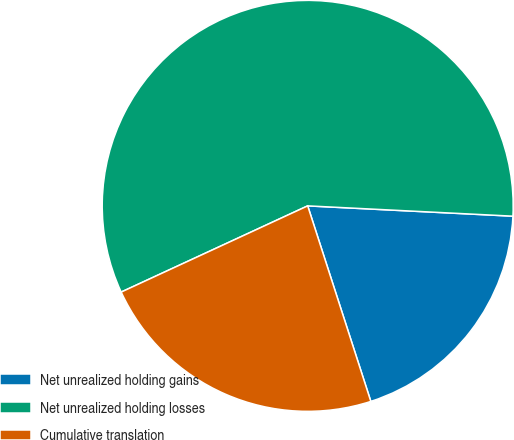Convert chart. <chart><loc_0><loc_0><loc_500><loc_500><pie_chart><fcel>Net unrealized holding gains<fcel>Net unrealized holding losses<fcel>Cumulative translation<nl><fcel>19.23%<fcel>57.69%<fcel>23.08%<nl></chart> 